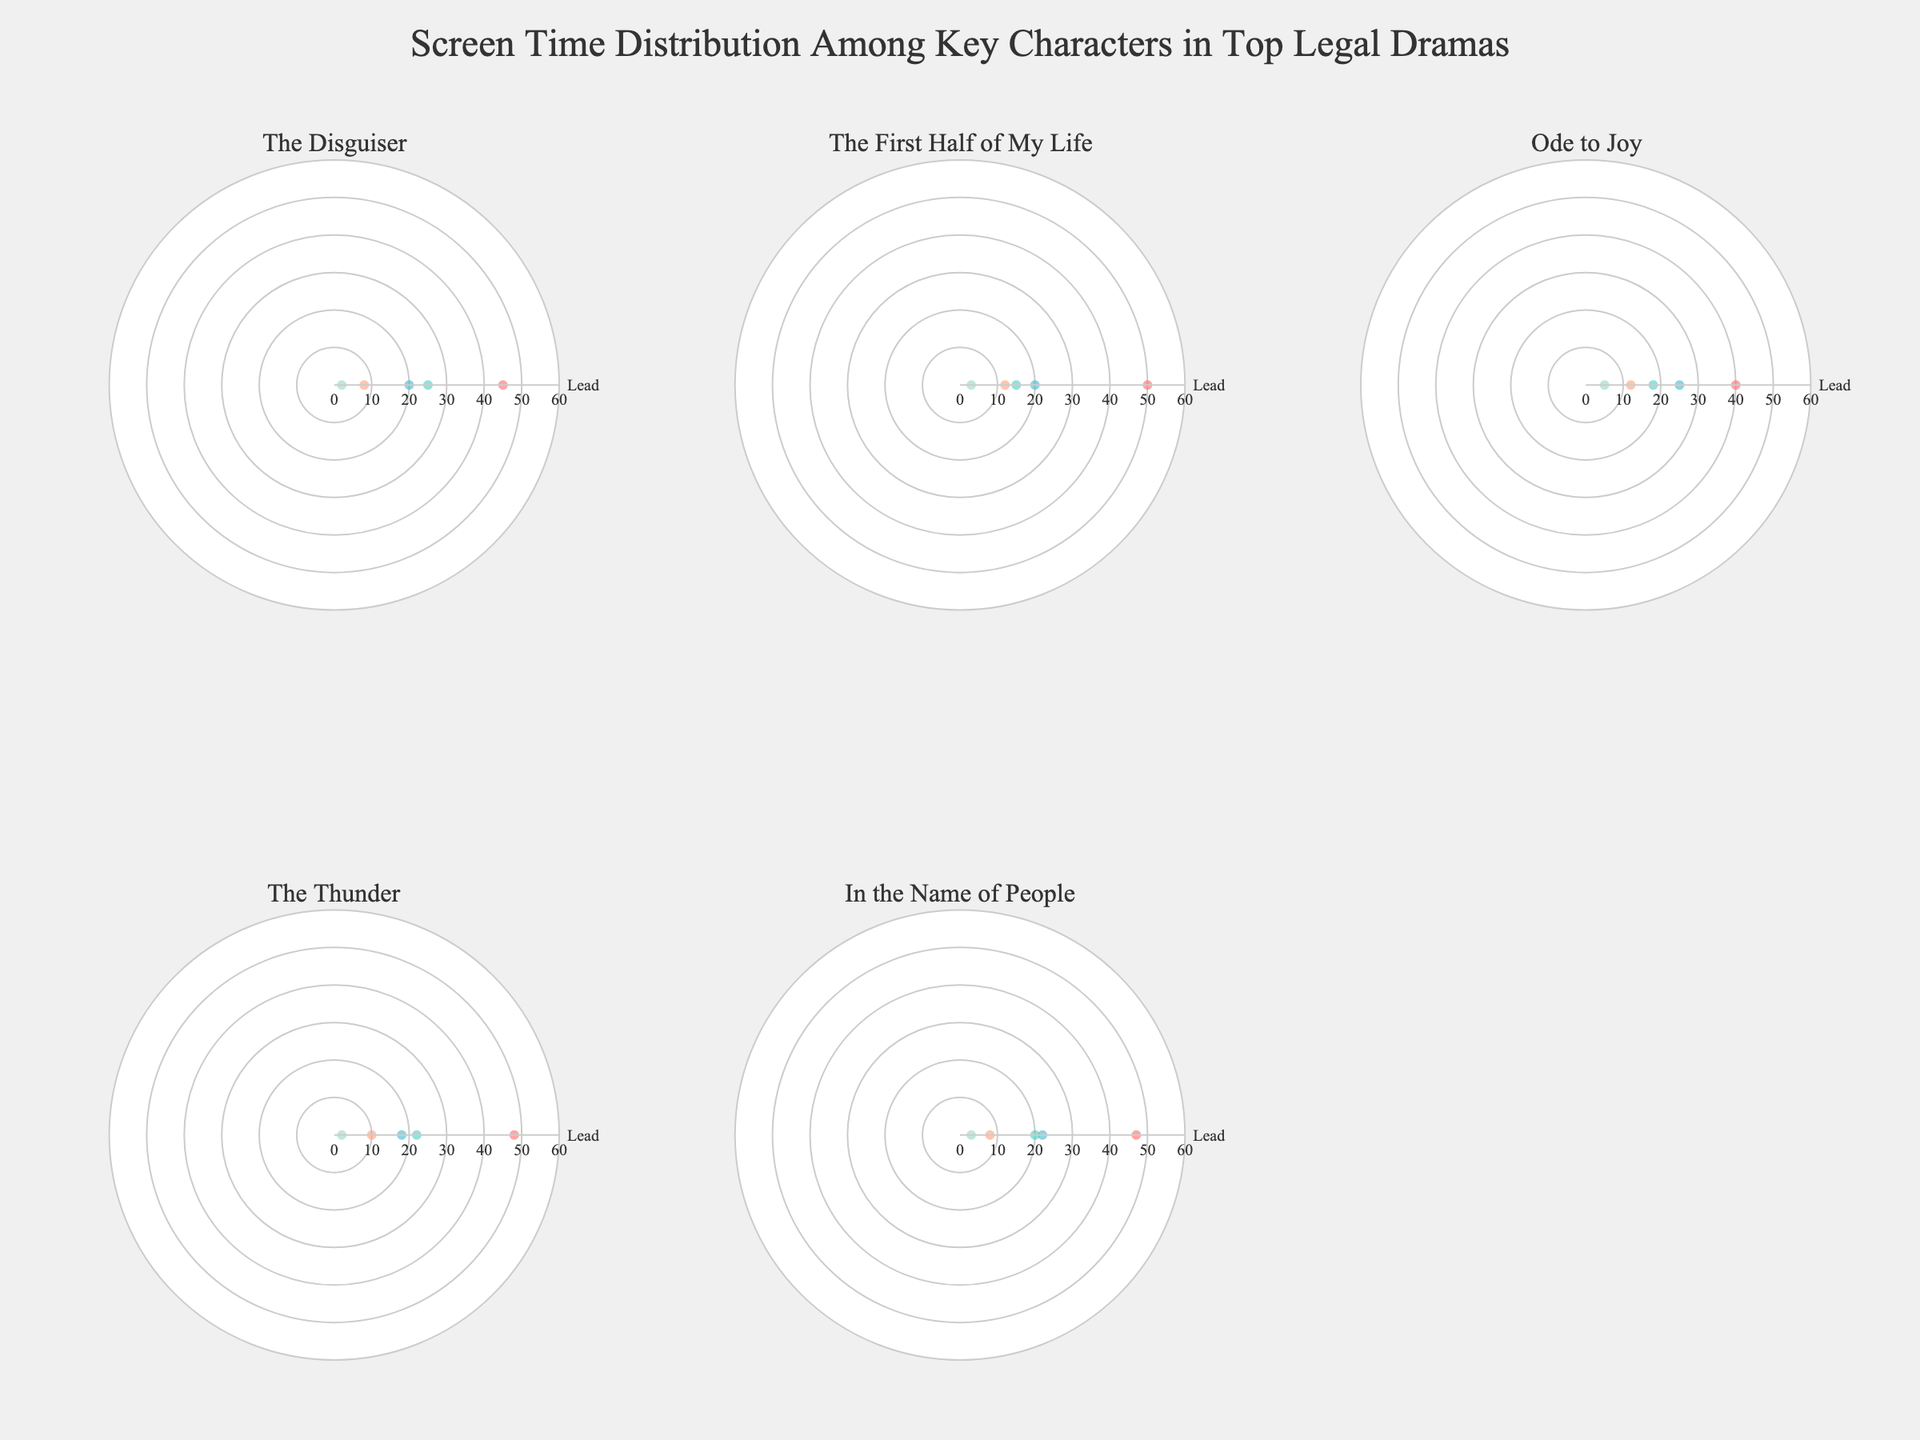what's the title of the figure? The title is located at the top-center of the figure. It provides a summary of what the figure is about. In this case, the title should convey that the figure displays the screen time distribution among key characters in top legal dramas.
Answer: Screen Time Distribution Among Key Characters in Top Legal Dramas Which legal drama has the highest screen time percentage for its lead character? By looking at the radar charts for each legal drama, observe the percentage values for the 'Lead' role. Compare these values to determine which lead character has the highest screen time percentage.
Answer: The First Half of My Life Which role generally has the lowest screen time percentage across the dramas? Examine the radar charts for each legal drama. Look at the screen time percentages for each role and identify which role consistently has the lowest values across the different dramas.
Answer: Judge For "The Thunder," what is the difference in screen time percentage between the Lead and Sidekick characters? On the radar chart for "The Thunder," note the screen time percentages for the Lead and Sidekick roles. Subtract the Sidekick's percentage from the Lead's percentage.
Answer: 38% Which two roles have the closest screen time percentages in "Ode to Joy"? For "Ode to Joy," observe the radar chart and compare the screen time percentages of each role. Identify which two roles have percentages that are closest in value.
Answer: Sidekick and Antagonist What is the average screen time percentage of Supporting characters across all dramas? Calculate the average by summing the screen time percentages of the Supporting characters in each of the dramas and then dividing by the number of dramas.
Answer: 21% In "The Disguiser," how much more screen time percentage does the Antagonist have compared to the Judge? Look at the radar chart for "The Disguiser," identify the screen time percentages for the Antagonist and Judge, and subtract the Judge's percentage from the Antagonist's percentage.
Answer: 23% Are there any dramas where the Judge's screen time percentage is above 5%? Examine the radar charts for all the dramas and check if the Judge's screen time percentage exceeds 5% in any of them.
Answer: No Which drama has the most evenly distributed screen time percentages among its key characters? To determine this, look at the radar charts for all dramas and compare the distribution of screen time percentages. The drama with percentages that are closest to each other indicates a more even distribution.
Answer: Ode to Joy 